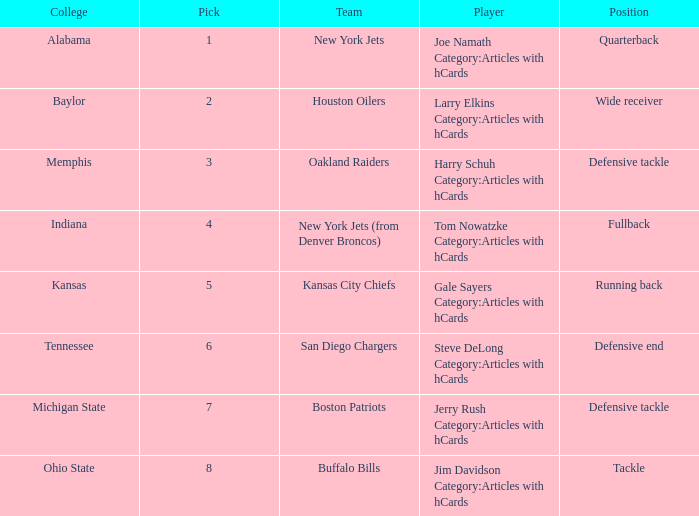What is the highest pick for the position of defensive end? 6.0. 